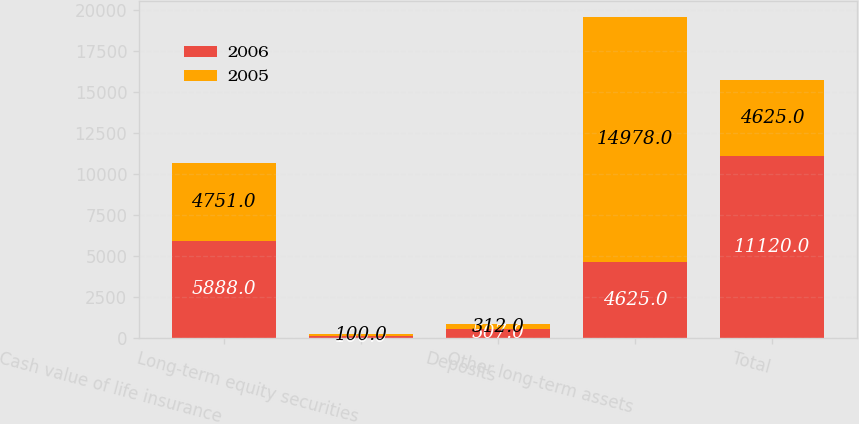<chart> <loc_0><loc_0><loc_500><loc_500><stacked_bar_chart><ecel><fcel>Cash value of life insurance<fcel>Long-term equity securities<fcel>Deposits<fcel>Other long-term assets<fcel>Total<nl><fcel>2006<fcel>5888<fcel>100<fcel>507<fcel>4625<fcel>11120<nl><fcel>2005<fcel>4751<fcel>100<fcel>312<fcel>14978<fcel>4625<nl></chart> 